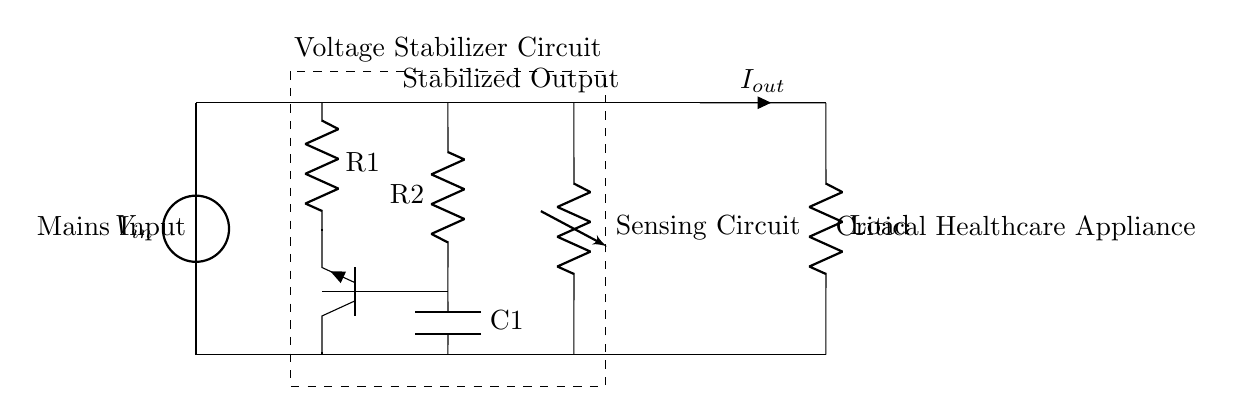What does the input voltage represent in this circuit? The input voltage represents the mains input, which is the source of power for the circuit. It is indicated as V_in on the diagram.
Answer: V_in What is the function of the sensing circuit? The sensing circuit is responsible for detecting the incoming voltage level to ensure the output voltage remains stable and within desired limits. It helps in regulating the voltage according to the healthcare appliances' requirements.
Answer: Sensing Circuit How many resistors are there in the circuit? There are two resistors present in the circuit. The resistors are labeled R1 and R2, as shown in the diagram.
Answer: 2 What type of transistor is used in this voltage stabilizer circuit? The diagram shows a transistor labeled as Tnpn, indicating that it is a NPN type transistor. This type of transistor is often used for amplification and switching within the circuit.
Answer: NPN What is the purpose of the capacitor in the circuit? The capacitor, labeled C1, is used for filtering and stabilizing the voltage output by smoothing out fluctuations, ensuring a consistent power supply to the critical healthcare appliances connected to the circuit.
Answer: Stabilization Which component provides the output current to the load? The output current to the load is provided by the voltage source output labeled as I_out, which connects to the critical healthcare appliance in the circuit.
Answer: I_out What does the dashed rectangle indicate in the diagram? The dashed rectangle represents the complete voltage stabilizer circuit area, highlighting where the main components for voltage regulation are housed, including the sensing circuit, resistors, and transistor.
Answer: Voltage Stabilizer Circuit 